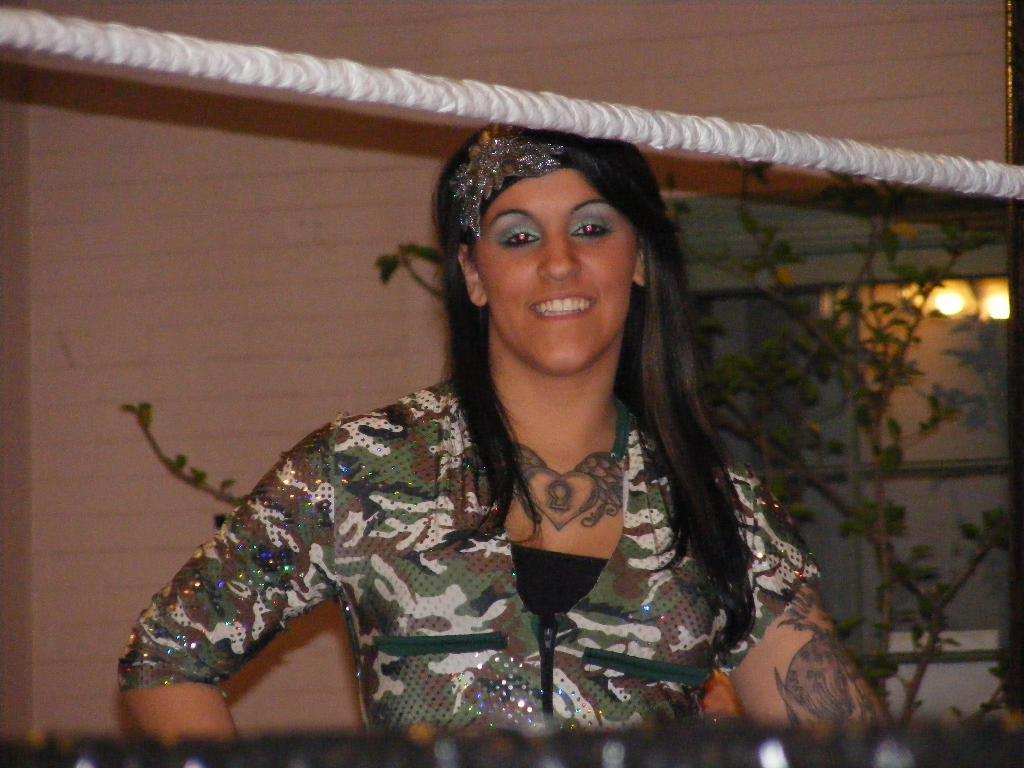What is the main subject of the image? There is a woman standing in the image. What is in front of the woman? There is a rope in front of the woman. What can be seen in the background of the image? There is a plant and a building in the background of the image. What type of sign is the woman holding in the image? There is no sign present in the image; the woman is not holding anything. 